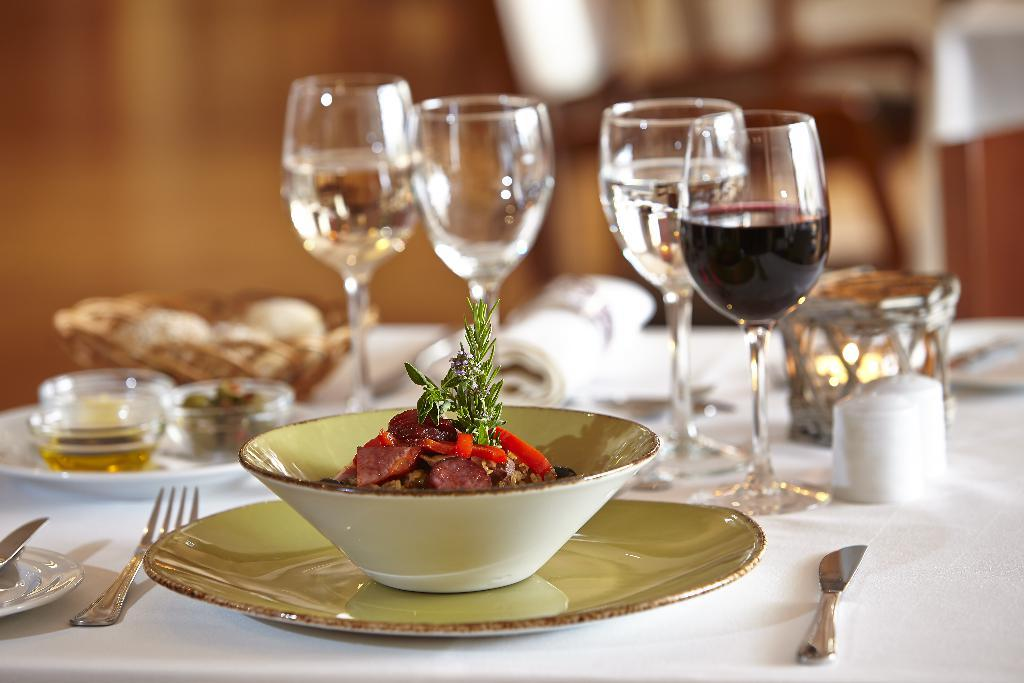What is in the bowl that is visible in the image? There is a bowl with food in the image. How is the bowl positioned on the table? The bowl is on a plate. What utensils can be seen in the image? There are forks and knives in the image. What items are present for serving or eating food? There are plates and napkins in the image. What beverages are visible in the image? There are glasses of wine in the image. Are there any other objects on the table? Yes, there are other objects on the table. How many friends are rewarded with food in the image? There is no indication of friends or rewards in the image; it simply shows a bowl of food, utensils, and other table settings. 